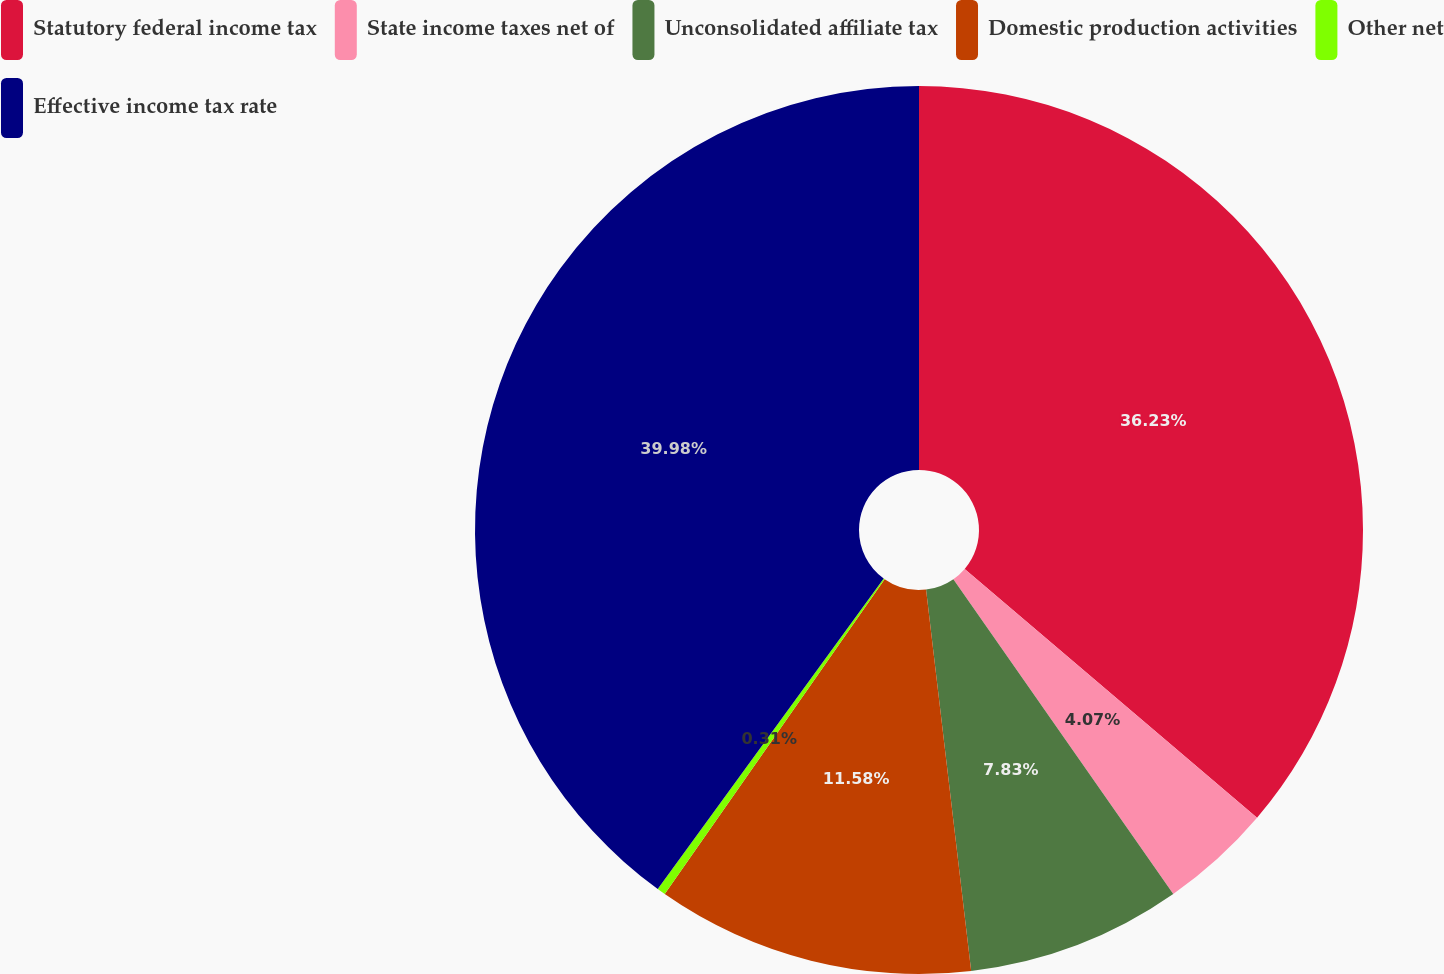Convert chart. <chart><loc_0><loc_0><loc_500><loc_500><pie_chart><fcel>Statutory federal income tax<fcel>State income taxes net of<fcel>Unconsolidated affiliate tax<fcel>Domestic production activities<fcel>Other net<fcel>Effective income tax rate<nl><fcel>36.23%<fcel>4.07%<fcel>7.83%<fcel>11.58%<fcel>0.31%<fcel>39.99%<nl></chart> 